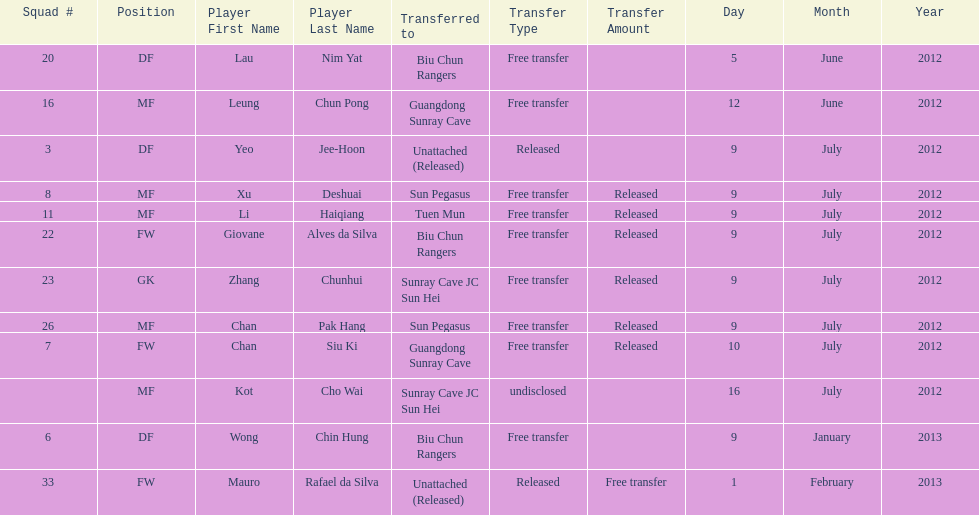How many consecutive players were released on july 9? 6. 